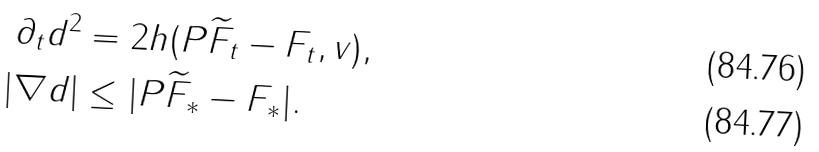<formula> <loc_0><loc_0><loc_500><loc_500>\partial _ { t } d ^ { 2 } & = 2 h ( P \widetilde { F } _ { t } - F _ { t } , v ) , \\ | \nabla d | & \leq | P \widetilde { F } _ { * } - F _ { * } | .</formula> 